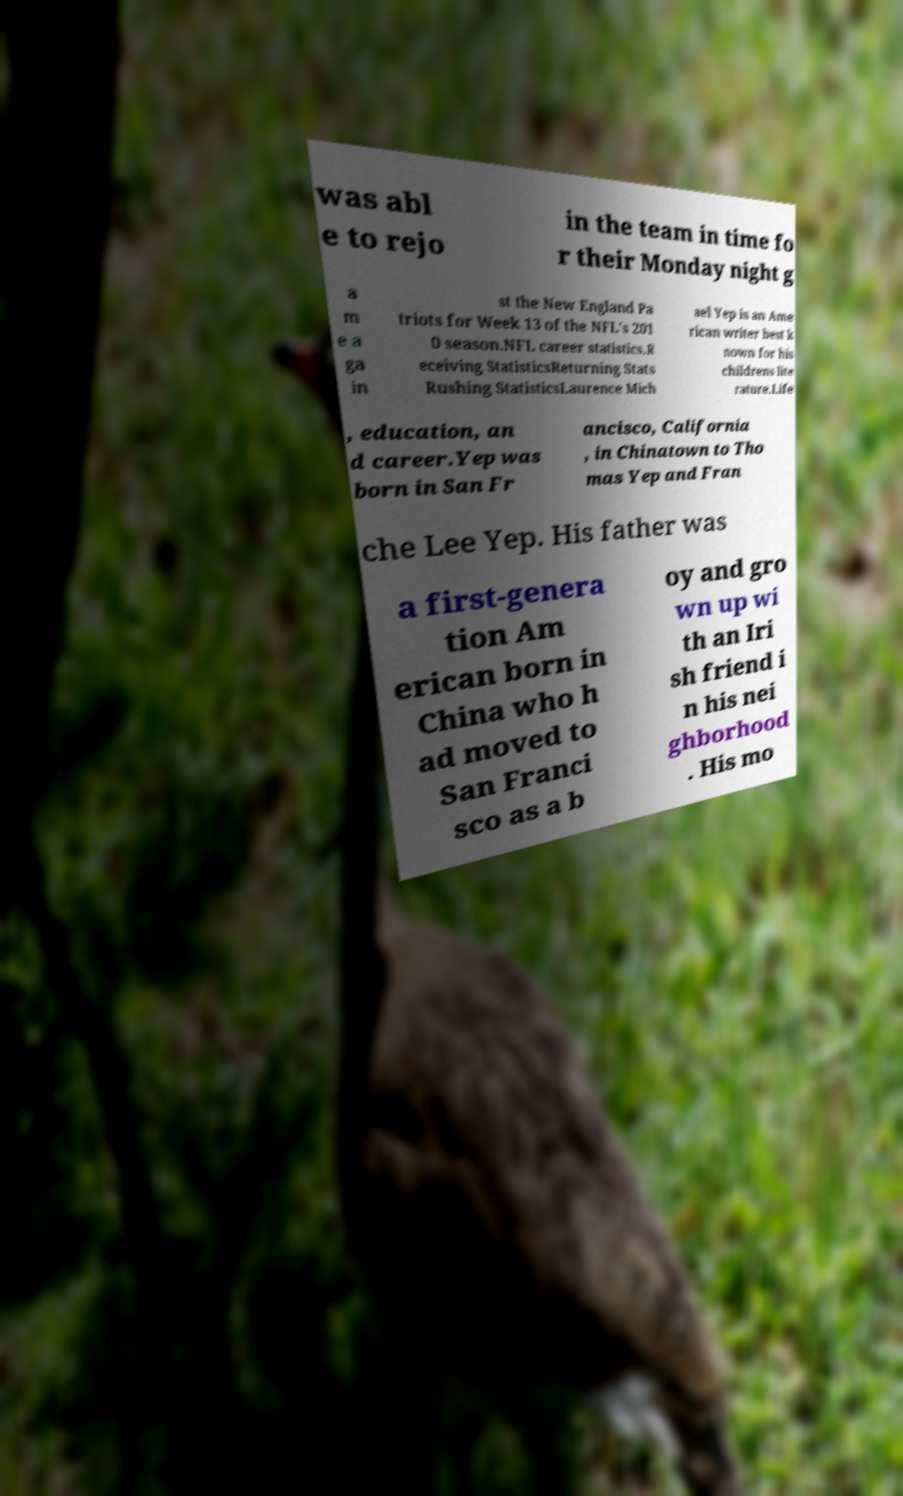There's text embedded in this image that I need extracted. Can you transcribe it verbatim? was abl e to rejo in the team in time fo r their Monday night g a m e a ga in st the New England Pa triots for Week 13 of the NFL's 201 0 season.NFL career statistics.R eceiving StatisticsReturning Stats Rushing StatisticsLaurence Mich ael Yep is an Ame rican writer best k nown for his childrens lite rature.Life , education, an d career.Yep was born in San Fr ancisco, California , in Chinatown to Tho mas Yep and Fran che Lee Yep. His father was a first-genera tion Am erican born in China who h ad moved to San Franci sco as a b oy and gro wn up wi th an Iri sh friend i n his nei ghborhood . His mo 